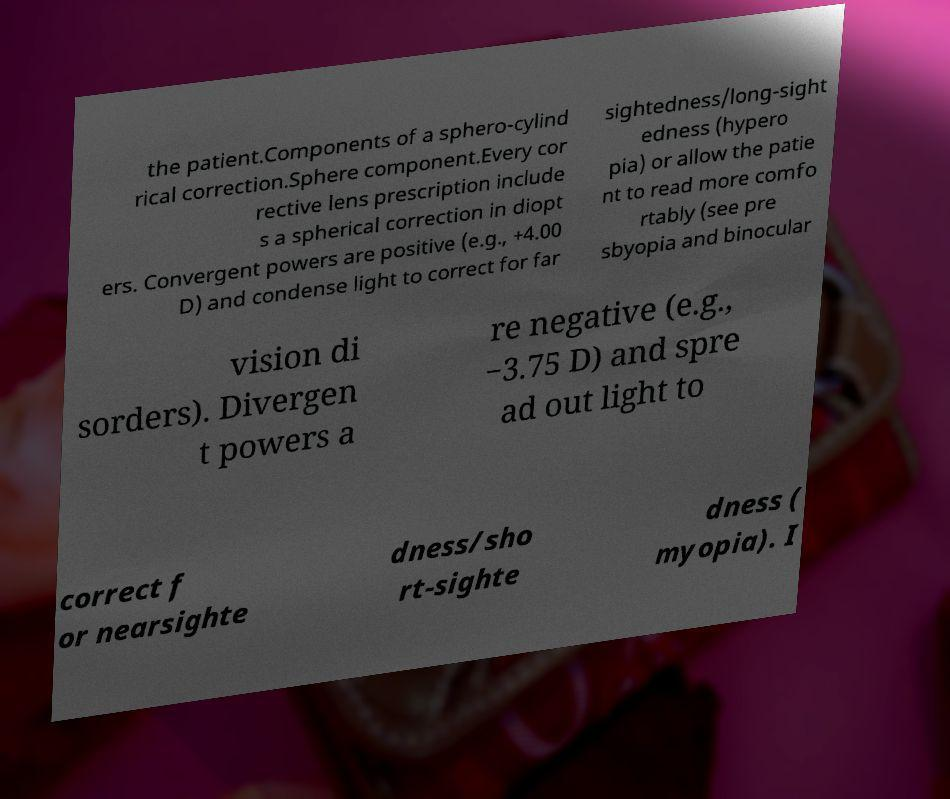I need the written content from this picture converted into text. Can you do that? the patient.Components of a sphero-cylind rical correction.Sphere component.Every cor rective lens prescription include s a spherical correction in diopt ers. Convergent powers are positive (e.g., +4.00 D) and condense light to correct for far sightedness/long-sight edness (hypero pia) or allow the patie nt to read more comfo rtably (see pre sbyopia and binocular vision di sorders). Divergen t powers a re negative (e.g., −3.75 D) and spre ad out light to correct f or nearsighte dness/sho rt-sighte dness ( myopia). I 